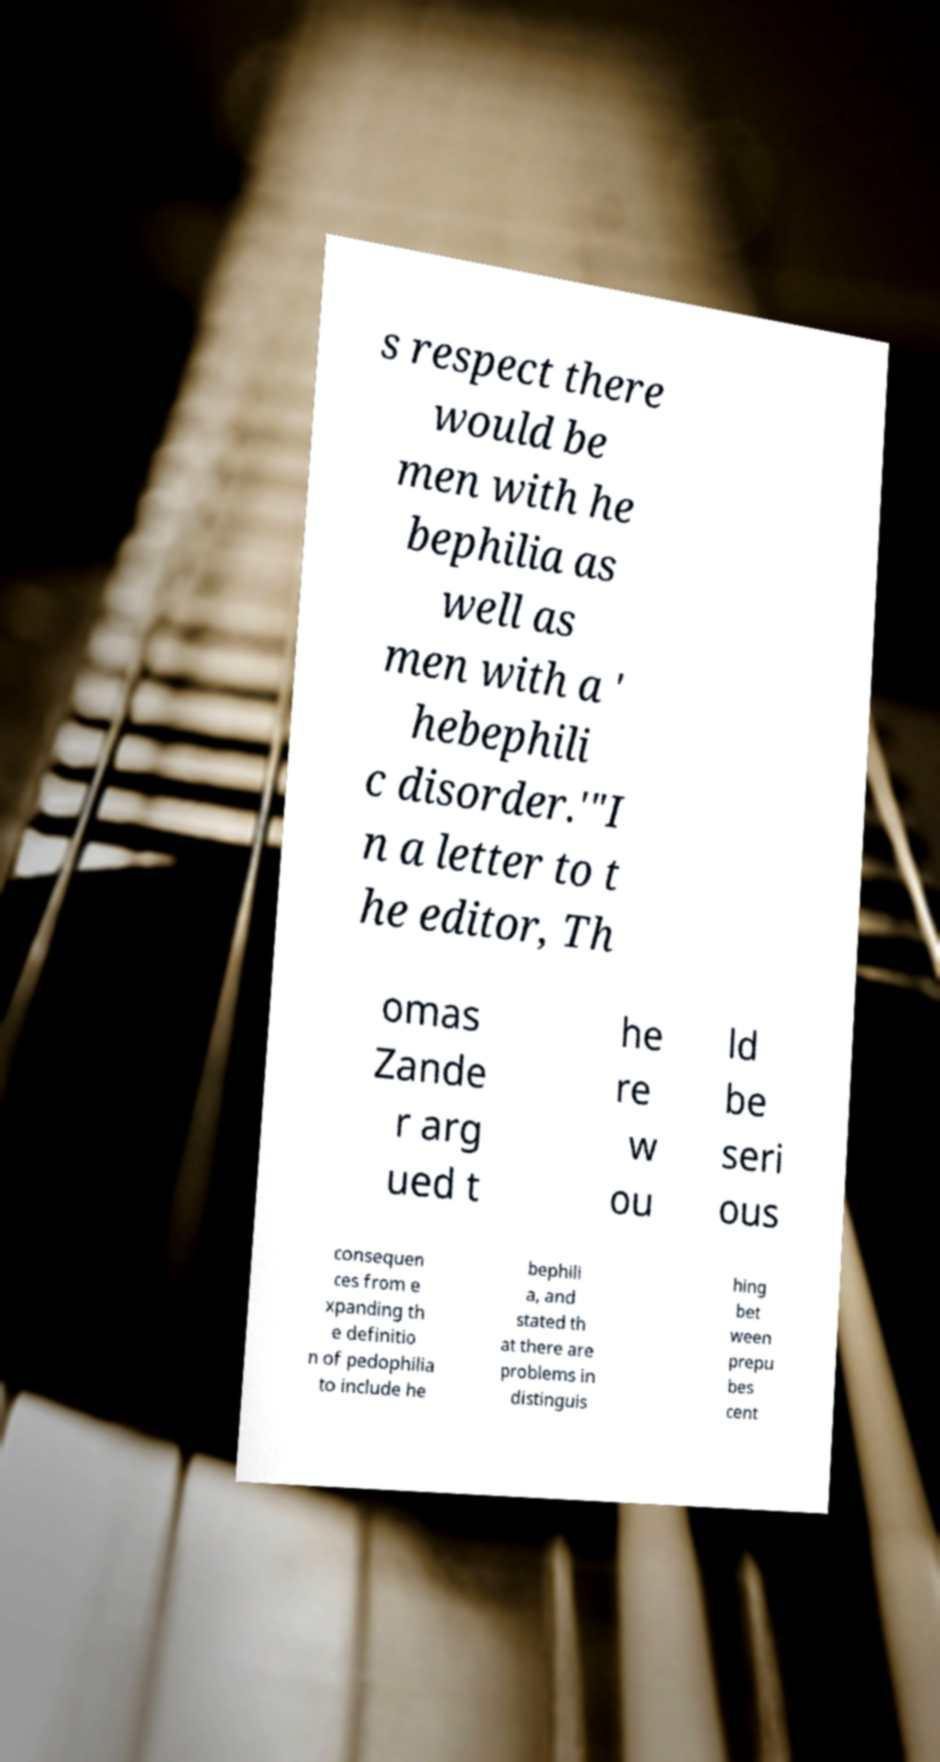Could you extract and type out the text from this image? s respect there would be men with he bephilia as well as men with a ' hebephili c disorder.'"I n a letter to t he editor, Th omas Zande r arg ued t he re w ou ld be seri ous consequen ces from e xpanding th e definitio n of pedophilia to include he bephili a, and stated th at there are problems in distinguis hing bet ween prepu bes cent 